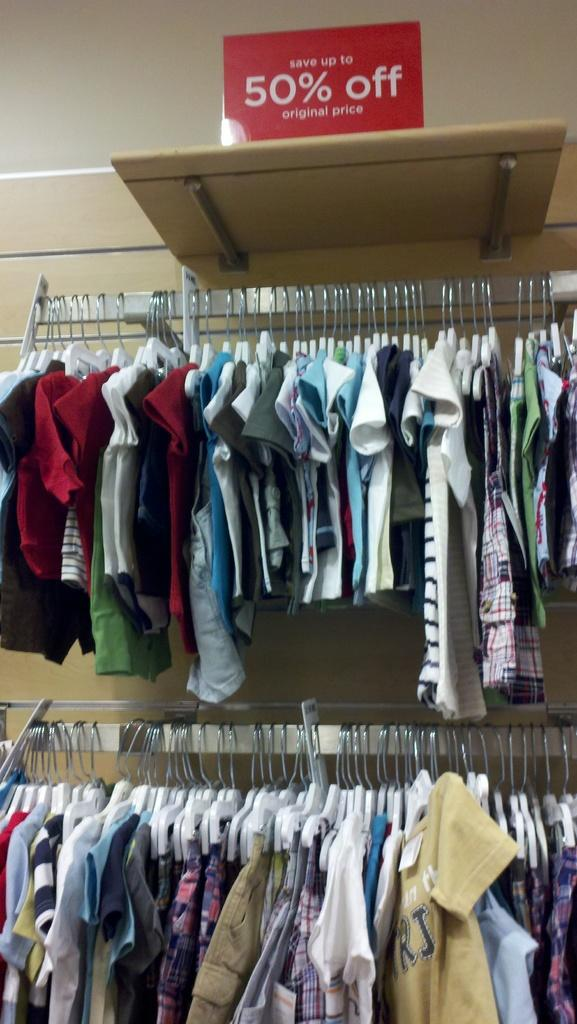<image>
Share a concise interpretation of the image provided. Clothes hang under a sign that says save up to 50 percent off. 